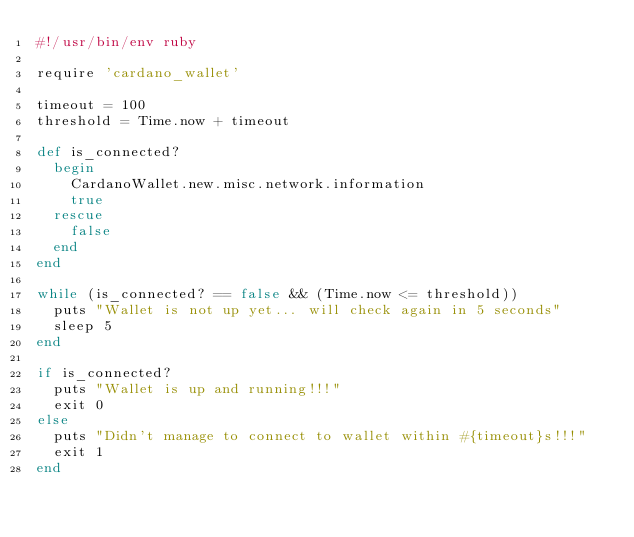Convert code to text. <code><loc_0><loc_0><loc_500><loc_500><_Ruby_>#!/usr/bin/env ruby

require 'cardano_wallet'

timeout = 100
threshold = Time.now + timeout

def is_connected?
  begin
    CardanoWallet.new.misc.network.information
    true
  rescue
    false
  end
end

while (is_connected? == false && (Time.now <= threshold))
  puts "Wallet is not up yet... will check again in 5 seconds"
  sleep 5
end

if is_connected?
  puts "Wallet is up and running!!!"
  exit 0
else
  puts "Didn't manage to connect to wallet within #{timeout}s!!!"
  exit 1
end
</code> 